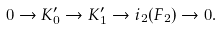Convert formula to latex. <formula><loc_0><loc_0><loc_500><loc_500>0 \to K _ { 0 } ^ { \prime } \to K _ { 1 } ^ { \prime } \to i _ { 2 } ( F _ { 2 } ) \to 0 .</formula> 